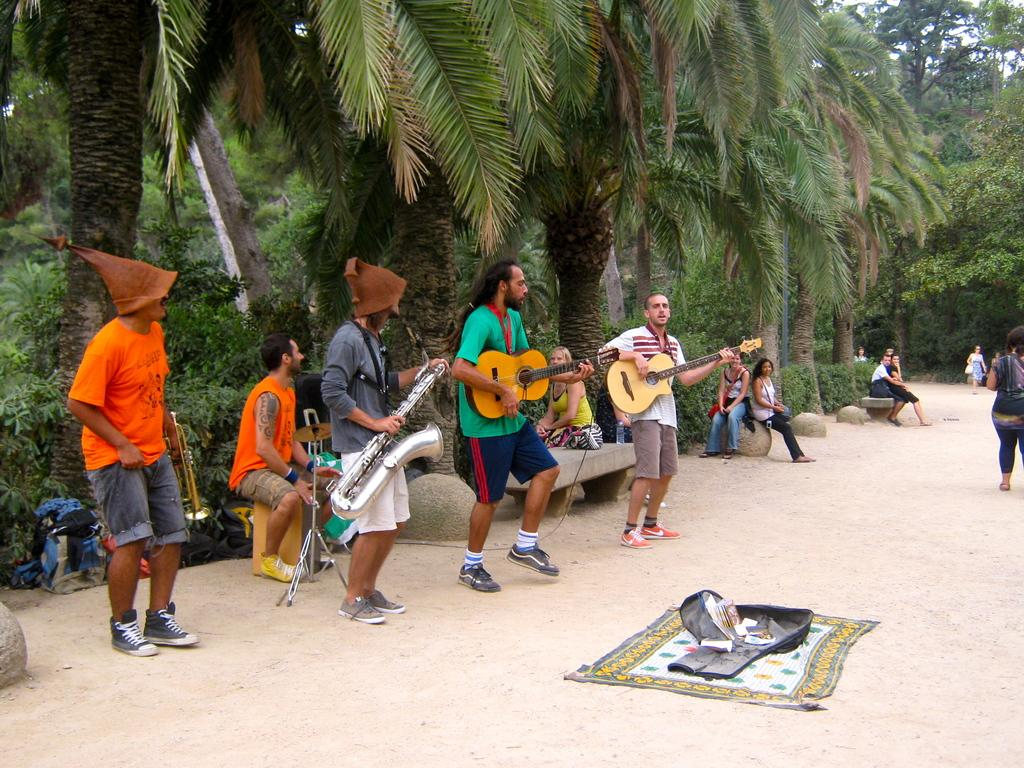What are the people in the image doing? The people in the image are playing musical instruments. Can you describe the setting in which the people are playing their instruments? There is a road visible in the image, which suggests that the setting might be outdoors or along a street. What type of parcel is being delivered to the group of people in the image? There is no parcel visible in the image, and therefore no such delivery can be observed. 